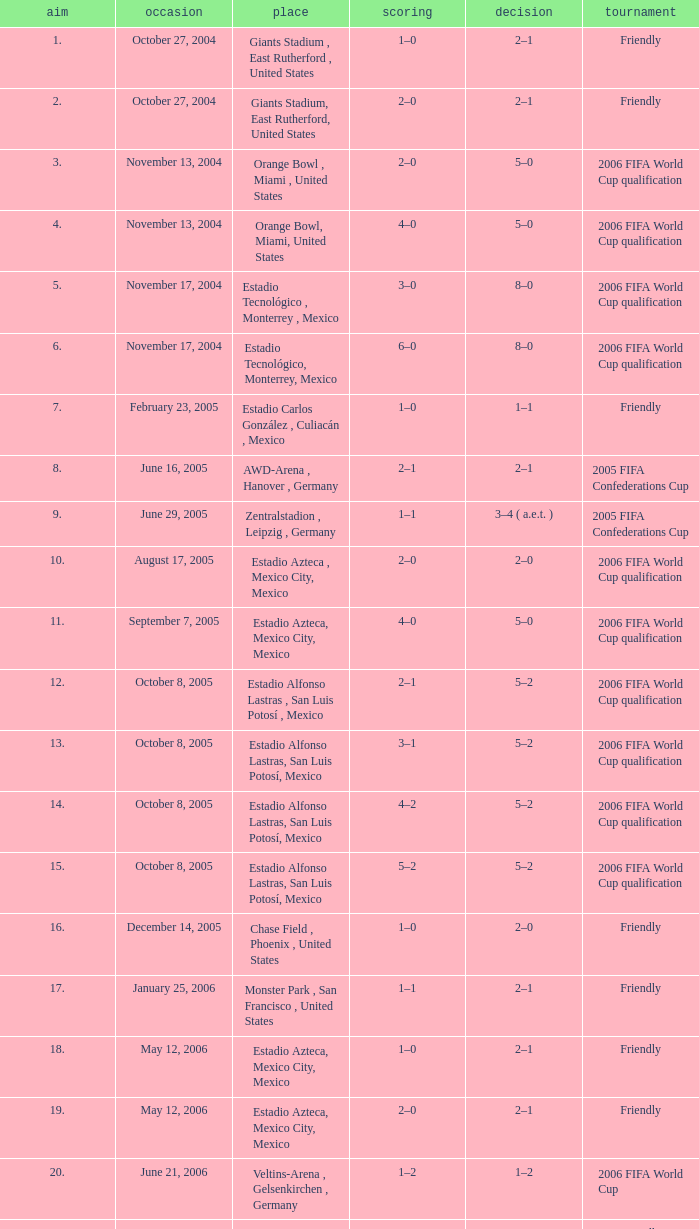Which Competition has a Venue of estadio alfonso lastras, san luis potosí, mexico, and a Goal larger than 15? Friendly. Parse the full table. {'header': ['aim', 'occasion', 'place', 'scoring', 'decision', 'tournament'], 'rows': [['1.', 'October 27, 2004', 'Giants Stadium , East Rutherford , United States', '1–0', '2–1', 'Friendly'], ['2.', 'October 27, 2004', 'Giants Stadium, East Rutherford, United States', '2–0', '2–1', 'Friendly'], ['3.', 'November 13, 2004', 'Orange Bowl , Miami , United States', '2–0', '5–0', '2006 FIFA World Cup qualification'], ['4.', 'November 13, 2004', 'Orange Bowl, Miami, United States', '4–0', '5–0', '2006 FIFA World Cup qualification'], ['5.', 'November 17, 2004', 'Estadio Tecnológico , Monterrey , Mexico', '3–0', '8–0', '2006 FIFA World Cup qualification'], ['6.', 'November 17, 2004', 'Estadio Tecnológico, Monterrey, Mexico', '6–0', '8–0', '2006 FIFA World Cup qualification'], ['7.', 'February 23, 2005', 'Estadio Carlos González , Culiacán , Mexico', '1–0', '1–1', 'Friendly'], ['8.', 'June 16, 2005', 'AWD-Arena , Hanover , Germany', '2–1', '2–1', '2005 FIFA Confederations Cup'], ['9.', 'June 29, 2005', 'Zentralstadion , Leipzig , Germany', '1–1', '3–4 ( a.e.t. )', '2005 FIFA Confederations Cup'], ['10.', 'August 17, 2005', 'Estadio Azteca , Mexico City, Mexico', '2–0', '2–0', '2006 FIFA World Cup qualification'], ['11.', 'September 7, 2005', 'Estadio Azteca, Mexico City, Mexico', '4–0', '5–0', '2006 FIFA World Cup qualification'], ['12.', 'October 8, 2005', 'Estadio Alfonso Lastras , San Luis Potosí , Mexico', '2–1', '5–2', '2006 FIFA World Cup qualification'], ['13.', 'October 8, 2005', 'Estadio Alfonso Lastras, San Luis Potosí, Mexico', '3–1', '5–2', '2006 FIFA World Cup qualification'], ['14.', 'October 8, 2005', 'Estadio Alfonso Lastras, San Luis Potosí, Mexico', '4–2', '5–2', '2006 FIFA World Cup qualification'], ['15.', 'October 8, 2005', 'Estadio Alfonso Lastras, San Luis Potosí, Mexico', '5–2', '5–2', '2006 FIFA World Cup qualification'], ['16.', 'December 14, 2005', 'Chase Field , Phoenix , United States', '1–0', '2–0', 'Friendly'], ['17.', 'January 25, 2006', 'Monster Park , San Francisco , United States', '1–1', '2–1', 'Friendly'], ['18.', 'May 12, 2006', 'Estadio Azteca, Mexico City, Mexico', '1–0', '2–1', 'Friendly'], ['19.', 'May 12, 2006', 'Estadio Azteca, Mexico City, Mexico', '2–0', '2–1', 'Friendly'], ['20.', 'June 21, 2006', 'Veltins-Arena , Gelsenkirchen , Germany', '1–2', '1–2', '2006 FIFA World Cup'], ['21.', 'June 2, 2007', 'Estadio Alfonso Lastras, San Luis Potosí, Mexico', '3–0', '4–0', 'Friendly']]} 